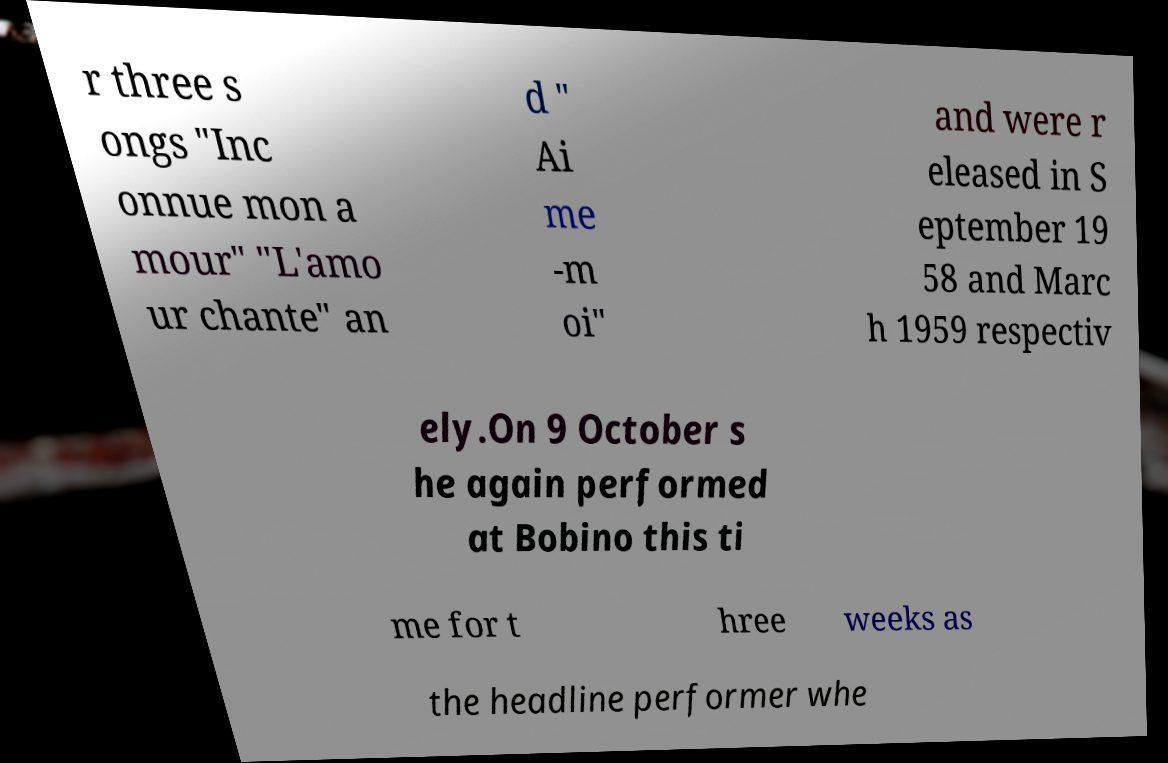Could you assist in decoding the text presented in this image and type it out clearly? r three s ongs "Inc onnue mon a mour" "L'amo ur chante" an d " Ai me -m oi" and were r eleased in S eptember 19 58 and Marc h 1959 respectiv ely.On 9 October s he again performed at Bobino this ti me for t hree weeks as the headline performer whe 